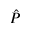<formula> <loc_0><loc_0><loc_500><loc_500>\hat { P }</formula> 